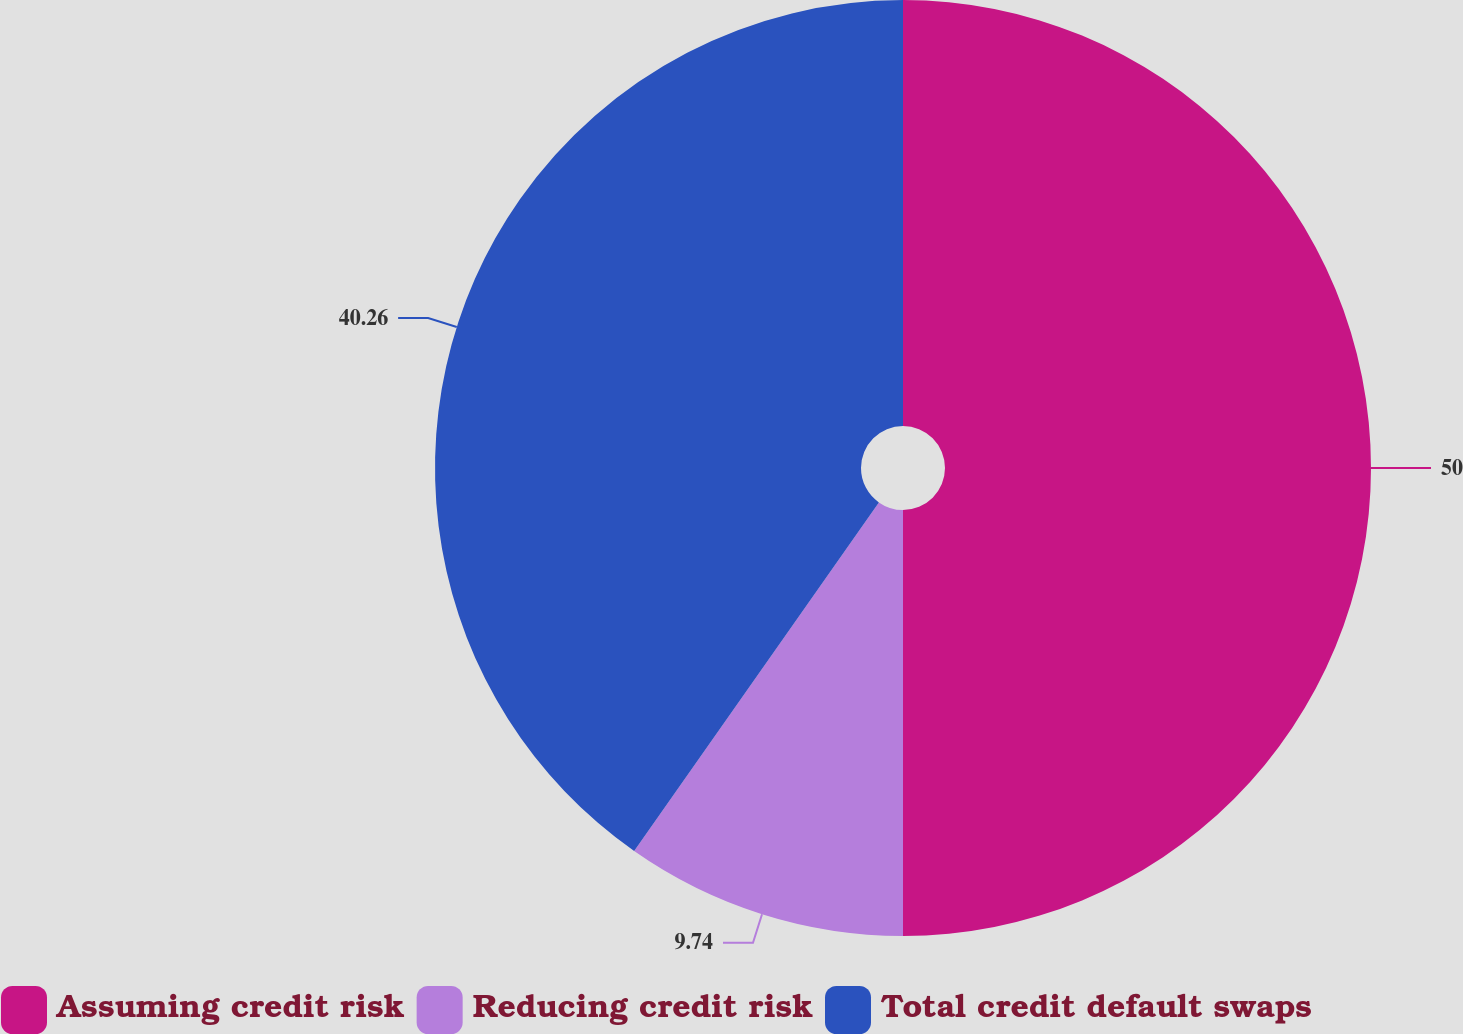Convert chart. <chart><loc_0><loc_0><loc_500><loc_500><pie_chart><fcel>Assuming credit risk<fcel>Reducing credit risk<fcel>Total credit default swaps<nl><fcel>50.0%<fcel>9.74%<fcel>40.26%<nl></chart> 